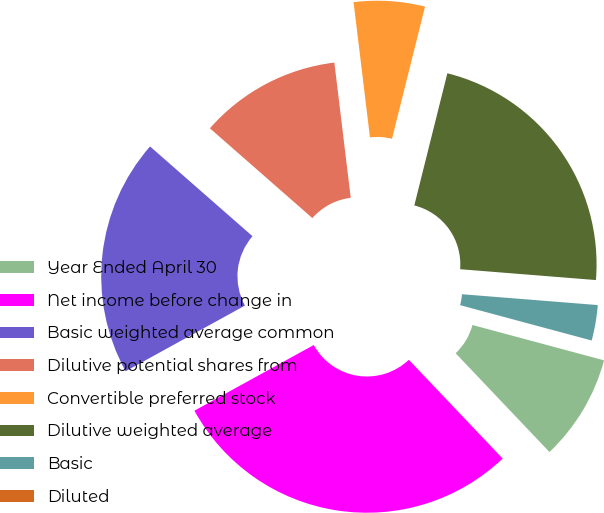Convert chart. <chart><loc_0><loc_0><loc_500><loc_500><pie_chart><fcel>Year Ended April 30<fcel>Net income before change in<fcel>Basic weighted average common<fcel>Dilutive potential shares from<fcel>Convertible preferred stock<fcel>Dilutive weighted average<fcel>Basic<fcel>Diluted<nl><fcel>8.73%<fcel>29.09%<fcel>19.46%<fcel>11.63%<fcel>5.82%<fcel>22.37%<fcel>2.91%<fcel>0.0%<nl></chart> 